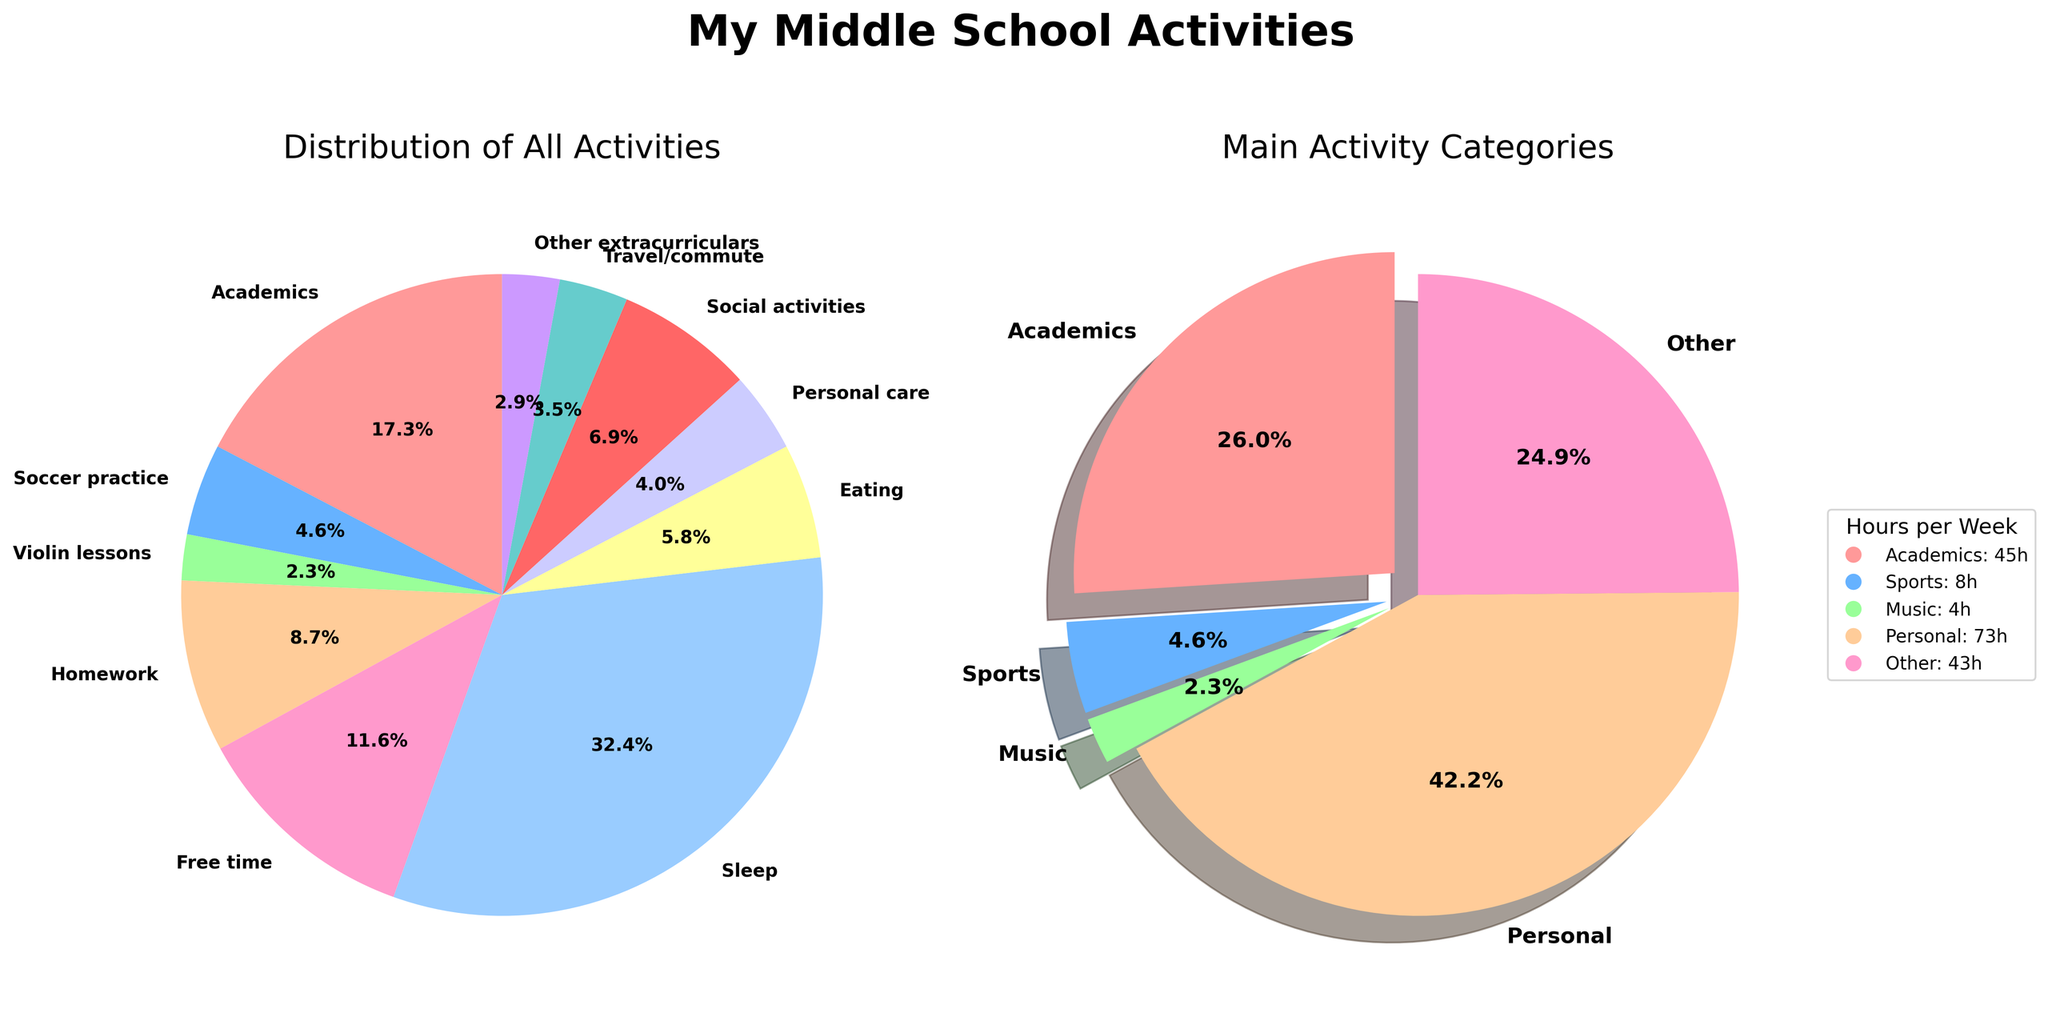What percentage of my time is spent on academics compared to free time? In the first pie chart, academics occupy a larger slice than free time. Academics is 30 hours and free time is 20 hours. Calculate the percentages for comparison: (30 / (30 + 20)) * 100 = 60% for academics and (20 / (30 + 20)) * 100 = 40% for free time.
Answer: Academics: 60%, Free time: 40% What is the largest single activity by hours? The largest slice in the first pie chart is labeled as sleep. The sleep activity shows 56 hours.
Answer: Sleep What categories are highlighted in the second pie chart? The second pie chart emphasizes three categories by slightly separating their slices: Academics, Sports, and Music, highlighting them distinctly compared to Personal and Other.
Answer: Academics, Sports, Music How does the time spent on personal activities compare to other categories in the second pie chart? In the second pie chart, Personal activities take up the largest portion at 73 hours, compared to Academics (45 hours), Sports (8 hours), Music (4 hours), and Other (43 hours). Personal is greater than all other categories.
Answer: Personal > All other categories What's the total time spent on sports and music activities? Refer to the main categories in the second pie chart. Sports are 8 hours, and Music is 4 hours. Sum them to get total time: 8 + 4 = 12 hours.
Answer: 12 hours What is the difference in hours between academics and personal activities in the second pie chart? Academics (45 hours) and Personal (73 hours) are provided in the main categories. Subtract to find the difference: 73 - 45 = 28 hours.
Answer: 28 hours If "Other extracurriculars" were doubled, how would that affect its percentage in the first pie chart? The current "Other extracurriculars" is 5 hours. If doubled, it becomes 10 hours. Find the new total: 173 hours (from 163 + 5). New percentage: (10 / 173) * 100 ≈ 5.8%.
Answer: ≈ 5.8% How does the time spent on academics compare to the combined time on homework and travel/commute? Academics: 30 hours. Combine Homework (15 hours) and Travel/commute (6 hours): 15 + 6 = 21 hours. Academics is greater: 30 vs. 21.
Answer: Academics > Homework + Travel/commute Which activity group consumes more than 1/3 of a middle schooler's time? The second pie chart shows main categories; Personal takes up 53.7% of the total time (73 hours out of 136 hours), clearly more than 1/3 (33.3%).
Answer: Personal 